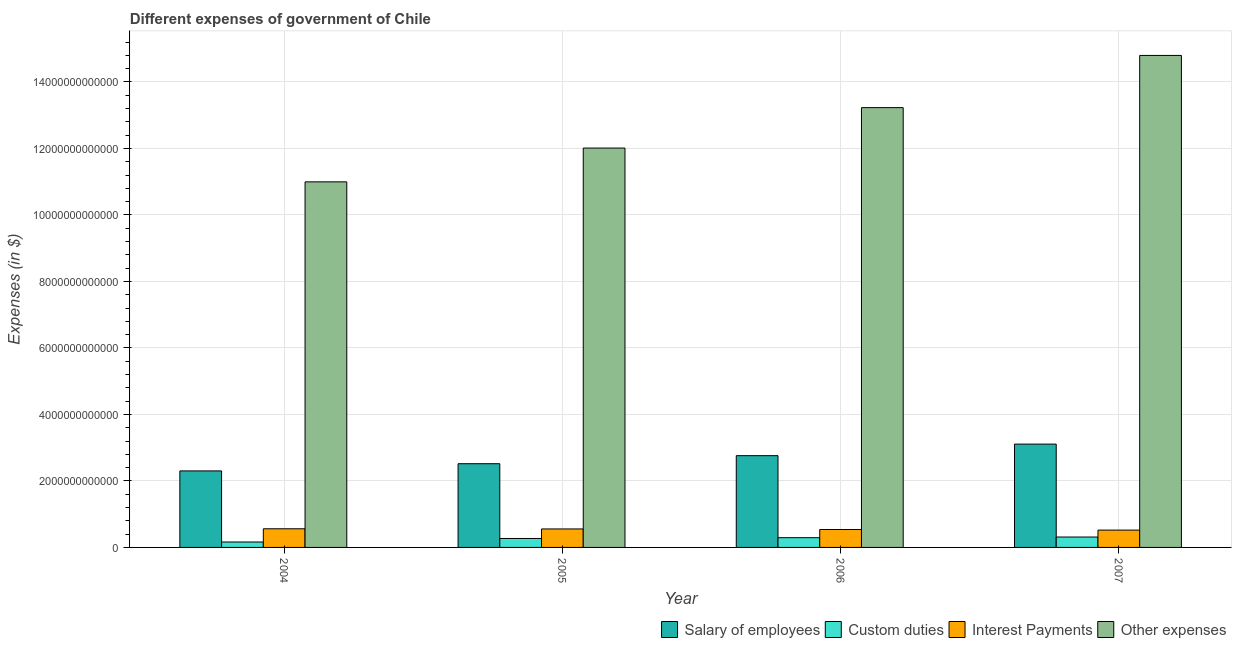How many different coloured bars are there?
Ensure brevity in your answer.  4. Are the number of bars per tick equal to the number of legend labels?
Make the answer very short. Yes. Are the number of bars on each tick of the X-axis equal?
Give a very brief answer. Yes. How many bars are there on the 1st tick from the right?
Provide a succinct answer. 4. In how many cases, is the number of bars for a given year not equal to the number of legend labels?
Ensure brevity in your answer.  0. What is the amount spent on salary of employees in 2004?
Make the answer very short. 2.30e+12. Across all years, what is the maximum amount spent on custom duties?
Offer a terse response. 3.13e+11. Across all years, what is the minimum amount spent on salary of employees?
Your answer should be very brief. 2.30e+12. What is the total amount spent on custom duties in the graph?
Give a very brief answer. 1.04e+12. What is the difference between the amount spent on other expenses in 2004 and that in 2007?
Ensure brevity in your answer.  -3.80e+12. What is the difference between the amount spent on other expenses in 2005 and the amount spent on custom duties in 2007?
Give a very brief answer. -2.79e+12. What is the average amount spent on other expenses per year?
Keep it short and to the point. 1.28e+13. In how many years, is the amount spent on interest payments greater than 5600000000000 $?
Your answer should be very brief. 0. What is the ratio of the amount spent on other expenses in 2004 to that in 2005?
Your answer should be very brief. 0.92. Is the amount spent on salary of employees in 2004 less than that in 2007?
Provide a short and direct response. Yes. Is the difference between the amount spent on interest payments in 2004 and 2006 greater than the difference between the amount spent on salary of employees in 2004 and 2006?
Offer a terse response. No. What is the difference between the highest and the second highest amount spent on custom duties?
Your answer should be compact. 2.01e+1. What is the difference between the highest and the lowest amount spent on interest payments?
Your answer should be very brief. 3.97e+1. What does the 2nd bar from the left in 2005 represents?
Make the answer very short. Custom duties. What does the 4th bar from the right in 2007 represents?
Keep it short and to the point. Salary of employees. How many bars are there?
Your answer should be compact. 16. How many years are there in the graph?
Offer a very short reply. 4. What is the difference between two consecutive major ticks on the Y-axis?
Provide a short and direct response. 2.00e+12. Does the graph contain any zero values?
Your answer should be compact. No. Where does the legend appear in the graph?
Your answer should be compact. Bottom right. How many legend labels are there?
Your answer should be very brief. 4. How are the legend labels stacked?
Make the answer very short. Horizontal. What is the title of the graph?
Ensure brevity in your answer.  Different expenses of government of Chile. Does "SF6 gas" appear as one of the legend labels in the graph?
Give a very brief answer. No. What is the label or title of the Y-axis?
Keep it short and to the point. Expenses (in $). What is the Expenses (in $) in Salary of employees in 2004?
Your answer should be compact. 2.30e+12. What is the Expenses (in $) of Custom duties in 2004?
Your answer should be very brief. 1.63e+11. What is the Expenses (in $) of Interest Payments in 2004?
Your answer should be very brief. 5.61e+11. What is the Expenses (in $) in Other expenses in 2004?
Your response must be concise. 1.10e+13. What is the Expenses (in $) in Salary of employees in 2005?
Your answer should be compact. 2.52e+12. What is the Expenses (in $) of Custom duties in 2005?
Offer a terse response. 2.69e+11. What is the Expenses (in $) of Interest Payments in 2005?
Provide a short and direct response. 5.56e+11. What is the Expenses (in $) in Other expenses in 2005?
Provide a succinct answer. 1.20e+13. What is the Expenses (in $) of Salary of employees in 2006?
Ensure brevity in your answer.  2.76e+12. What is the Expenses (in $) in Custom duties in 2006?
Provide a succinct answer. 2.93e+11. What is the Expenses (in $) of Interest Payments in 2006?
Your response must be concise. 5.39e+11. What is the Expenses (in $) of Other expenses in 2006?
Give a very brief answer. 1.32e+13. What is the Expenses (in $) in Salary of employees in 2007?
Offer a terse response. 3.11e+12. What is the Expenses (in $) of Custom duties in 2007?
Give a very brief answer. 3.13e+11. What is the Expenses (in $) of Interest Payments in 2007?
Provide a succinct answer. 5.21e+11. What is the Expenses (in $) in Other expenses in 2007?
Your answer should be very brief. 1.48e+13. Across all years, what is the maximum Expenses (in $) in Salary of employees?
Your answer should be compact. 3.11e+12. Across all years, what is the maximum Expenses (in $) in Custom duties?
Your answer should be compact. 3.13e+11. Across all years, what is the maximum Expenses (in $) of Interest Payments?
Keep it short and to the point. 5.61e+11. Across all years, what is the maximum Expenses (in $) of Other expenses?
Your answer should be very brief. 1.48e+13. Across all years, what is the minimum Expenses (in $) in Salary of employees?
Make the answer very short. 2.30e+12. Across all years, what is the minimum Expenses (in $) of Custom duties?
Provide a succinct answer. 1.63e+11. Across all years, what is the minimum Expenses (in $) of Interest Payments?
Make the answer very short. 5.21e+11. Across all years, what is the minimum Expenses (in $) in Other expenses?
Make the answer very short. 1.10e+13. What is the total Expenses (in $) in Salary of employees in the graph?
Provide a short and direct response. 1.07e+13. What is the total Expenses (in $) in Custom duties in the graph?
Offer a terse response. 1.04e+12. What is the total Expenses (in $) of Interest Payments in the graph?
Offer a very short reply. 2.18e+12. What is the total Expenses (in $) in Other expenses in the graph?
Your response must be concise. 5.10e+13. What is the difference between the Expenses (in $) in Salary of employees in 2004 and that in 2005?
Offer a terse response. -2.16e+11. What is the difference between the Expenses (in $) of Custom duties in 2004 and that in 2005?
Ensure brevity in your answer.  -1.06e+11. What is the difference between the Expenses (in $) in Interest Payments in 2004 and that in 2005?
Offer a terse response. 4.98e+09. What is the difference between the Expenses (in $) in Other expenses in 2004 and that in 2005?
Your response must be concise. -1.02e+12. What is the difference between the Expenses (in $) of Salary of employees in 2004 and that in 2006?
Make the answer very short. -4.58e+11. What is the difference between the Expenses (in $) of Custom duties in 2004 and that in 2006?
Offer a terse response. -1.30e+11. What is the difference between the Expenses (in $) of Interest Payments in 2004 and that in 2006?
Offer a terse response. 2.20e+1. What is the difference between the Expenses (in $) in Other expenses in 2004 and that in 2006?
Offer a very short reply. -2.23e+12. What is the difference between the Expenses (in $) in Salary of employees in 2004 and that in 2007?
Provide a short and direct response. -8.06e+11. What is the difference between the Expenses (in $) in Custom duties in 2004 and that in 2007?
Your answer should be compact. -1.50e+11. What is the difference between the Expenses (in $) of Interest Payments in 2004 and that in 2007?
Provide a short and direct response. 3.97e+1. What is the difference between the Expenses (in $) in Other expenses in 2004 and that in 2007?
Your answer should be very brief. -3.80e+12. What is the difference between the Expenses (in $) in Salary of employees in 2005 and that in 2006?
Ensure brevity in your answer.  -2.42e+11. What is the difference between the Expenses (in $) of Custom duties in 2005 and that in 2006?
Ensure brevity in your answer.  -2.38e+1. What is the difference between the Expenses (in $) in Interest Payments in 2005 and that in 2006?
Your response must be concise. 1.70e+1. What is the difference between the Expenses (in $) of Other expenses in 2005 and that in 2006?
Provide a succinct answer. -1.22e+12. What is the difference between the Expenses (in $) in Salary of employees in 2005 and that in 2007?
Ensure brevity in your answer.  -5.90e+11. What is the difference between the Expenses (in $) in Custom duties in 2005 and that in 2007?
Offer a very short reply. -4.39e+1. What is the difference between the Expenses (in $) in Interest Payments in 2005 and that in 2007?
Ensure brevity in your answer.  3.47e+1. What is the difference between the Expenses (in $) of Other expenses in 2005 and that in 2007?
Your response must be concise. -2.79e+12. What is the difference between the Expenses (in $) in Salary of employees in 2006 and that in 2007?
Keep it short and to the point. -3.48e+11. What is the difference between the Expenses (in $) in Custom duties in 2006 and that in 2007?
Give a very brief answer. -2.01e+1. What is the difference between the Expenses (in $) in Interest Payments in 2006 and that in 2007?
Your response must be concise. 1.77e+1. What is the difference between the Expenses (in $) in Other expenses in 2006 and that in 2007?
Ensure brevity in your answer.  -1.57e+12. What is the difference between the Expenses (in $) in Salary of employees in 2004 and the Expenses (in $) in Custom duties in 2005?
Give a very brief answer. 2.03e+12. What is the difference between the Expenses (in $) in Salary of employees in 2004 and the Expenses (in $) in Interest Payments in 2005?
Provide a succinct answer. 1.75e+12. What is the difference between the Expenses (in $) in Salary of employees in 2004 and the Expenses (in $) in Other expenses in 2005?
Your answer should be very brief. -9.71e+12. What is the difference between the Expenses (in $) in Custom duties in 2004 and the Expenses (in $) in Interest Payments in 2005?
Offer a very short reply. -3.93e+11. What is the difference between the Expenses (in $) of Custom duties in 2004 and the Expenses (in $) of Other expenses in 2005?
Your answer should be compact. -1.19e+13. What is the difference between the Expenses (in $) in Interest Payments in 2004 and the Expenses (in $) in Other expenses in 2005?
Provide a succinct answer. -1.15e+13. What is the difference between the Expenses (in $) in Salary of employees in 2004 and the Expenses (in $) in Custom duties in 2006?
Give a very brief answer. 2.01e+12. What is the difference between the Expenses (in $) of Salary of employees in 2004 and the Expenses (in $) of Interest Payments in 2006?
Your response must be concise. 1.76e+12. What is the difference between the Expenses (in $) in Salary of employees in 2004 and the Expenses (in $) in Other expenses in 2006?
Offer a terse response. -1.09e+13. What is the difference between the Expenses (in $) of Custom duties in 2004 and the Expenses (in $) of Interest Payments in 2006?
Your answer should be compact. -3.76e+11. What is the difference between the Expenses (in $) of Custom duties in 2004 and the Expenses (in $) of Other expenses in 2006?
Ensure brevity in your answer.  -1.31e+13. What is the difference between the Expenses (in $) of Interest Payments in 2004 and the Expenses (in $) of Other expenses in 2006?
Your answer should be compact. -1.27e+13. What is the difference between the Expenses (in $) in Salary of employees in 2004 and the Expenses (in $) in Custom duties in 2007?
Make the answer very short. 1.99e+12. What is the difference between the Expenses (in $) of Salary of employees in 2004 and the Expenses (in $) of Interest Payments in 2007?
Give a very brief answer. 1.78e+12. What is the difference between the Expenses (in $) in Salary of employees in 2004 and the Expenses (in $) in Other expenses in 2007?
Your answer should be very brief. -1.25e+13. What is the difference between the Expenses (in $) in Custom duties in 2004 and the Expenses (in $) in Interest Payments in 2007?
Offer a very short reply. -3.58e+11. What is the difference between the Expenses (in $) in Custom duties in 2004 and the Expenses (in $) in Other expenses in 2007?
Provide a short and direct response. -1.46e+13. What is the difference between the Expenses (in $) of Interest Payments in 2004 and the Expenses (in $) of Other expenses in 2007?
Make the answer very short. -1.42e+13. What is the difference between the Expenses (in $) of Salary of employees in 2005 and the Expenses (in $) of Custom duties in 2006?
Your answer should be very brief. 2.23e+12. What is the difference between the Expenses (in $) of Salary of employees in 2005 and the Expenses (in $) of Interest Payments in 2006?
Make the answer very short. 1.98e+12. What is the difference between the Expenses (in $) of Salary of employees in 2005 and the Expenses (in $) of Other expenses in 2006?
Make the answer very short. -1.07e+13. What is the difference between the Expenses (in $) of Custom duties in 2005 and the Expenses (in $) of Interest Payments in 2006?
Your response must be concise. -2.70e+11. What is the difference between the Expenses (in $) of Custom duties in 2005 and the Expenses (in $) of Other expenses in 2006?
Keep it short and to the point. -1.30e+13. What is the difference between the Expenses (in $) in Interest Payments in 2005 and the Expenses (in $) in Other expenses in 2006?
Make the answer very short. -1.27e+13. What is the difference between the Expenses (in $) in Salary of employees in 2005 and the Expenses (in $) in Custom duties in 2007?
Provide a short and direct response. 2.20e+12. What is the difference between the Expenses (in $) in Salary of employees in 2005 and the Expenses (in $) in Interest Payments in 2007?
Your answer should be compact. 2.00e+12. What is the difference between the Expenses (in $) in Salary of employees in 2005 and the Expenses (in $) in Other expenses in 2007?
Give a very brief answer. -1.23e+13. What is the difference between the Expenses (in $) in Custom duties in 2005 and the Expenses (in $) in Interest Payments in 2007?
Your response must be concise. -2.52e+11. What is the difference between the Expenses (in $) of Custom duties in 2005 and the Expenses (in $) of Other expenses in 2007?
Offer a very short reply. -1.45e+13. What is the difference between the Expenses (in $) in Interest Payments in 2005 and the Expenses (in $) in Other expenses in 2007?
Offer a terse response. -1.42e+13. What is the difference between the Expenses (in $) of Salary of employees in 2006 and the Expenses (in $) of Custom duties in 2007?
Your response must be concise. 2.45e+12. What is the difference between the Expenses (in $) in Salary of employees in 2006 and the Expenses (in $) in Interest Payments in 2007?
Provide a short and direct response. 2.24e+12. What is the difference between the Expenses (in $) in Salary of employees in 2006 and the Expenses (in $) in Other expenses in 2007?
Offer a very short reply. -1.20e+13. What is the difference between the Expenses (in $) of Custom duties in 2006 and the Expenses (in $) of Interest Payments in 2007?
Keep it short and to the point. -2.28e+11. What is the difference between the Expenses (in $) in Custom duties in 2006 and the Expenses (in $) in Other expenses in 2007?
Make the answer very short. -1.45e+13. What is the difference between the Expenses (in $) in Interest Payments in 2006 and the Expenses (in $) in Other expenses in 2007?
Your response must be concise. -1.43e+13. What is the average Expenses (in $) of Salary of employees per year?
Your answer should be very brief. 2.67e+12. What is the average Expenses (in $) in Custom duties per year?
Provide a succinct answer. 2.60e+11. What is the average Expenses (in $) of Interest Payments per year?
Your answer should be very brief. 5.44e+11. What is the average Expenses (in $) of Other expenses per year?
Offer a terse response. 1.28e+13. In the year 2004, what is the difference between the Expenses (in $) of Salary of employees and Expenses (in $) of Custom duties?
Keep it short and to the point. 2.14e+12. In the year 2004, what is the difference between the Expenses (in $) of Salary of employees and Expenses (in $) of Interest Payments?
Your answer should be compact. 1.74e+12. In the year 2004, what is the difference between the Expenses (in $) in Salary of employees and Expenses (in $) in Other expenses?
Provide a succinct answer. -8.69e+12. In the year 2004, what is the difference between the Expenses (in $) in Custom duties and Expenses (in $) in Interest Payments?
Keep it short and to the point. -3.98e+11. In the year 2004, what is the difference between the Expenses (in $) in Custom duties and Expenses (in $) in Other expenses?
Your answer should be very brief. -1.08e+13. In the year 2004, what is the difference between the Expenses (in $) in Interest Payments and Expenses (in $) in Other expenses?
Give a very brief answer. -1.04e+13. In the year 2005, what is the difference between the Expenses (in $) of Salary of employees and Expenses (in $) of Custom duties?
Your answer should be very brief. 2.25e+12. In the year 2005, what is the difference between the Expenses (in $) in Salary of employees and Expenses (in $) in Interest Payments?
Provide a succinct answer. 1.96e+12. In the year 2005, what is the difference between the Expenses (in $) in Salary of employees and Expenses (in $) in Other expenses?
Your answer should be very brief. -9.50e+12. In the year 2005, what is the difference between the Expenses (in $) in Custom duties and Expenses (in $) in Interest Payments?
Offer a very short reply. -2.87e+11. In the year 2005, what is the difference between the Expenses (in $) in Custom duties and Expenses (in $) in Other expenses?
Your answer should be very brief. -1.17e+13. In the year 2005, what is the difference between the Expenses (in $) in Interest Payments and Expenses (in $) in Other expenses?
Provide a short and direct response. -1.15e+13. In the year 2006, what is the difference between the Expenses (in $) of Salary of employees and Expenses (in $) of Custom duties?
Offer a terse response. 2.47e+12. In the year 2006, what is the difference between the Expenses (in $) of Salary of employees and Expenses (in $) of Interest Payments?
Your answer should be very brief. 2.22e+12. In the year 2006, what is the difference between the Expenses (in $) in Salary of employees and Expenses (in $) in Other expenses?
Keep it short and to the point. -1.05e+13. In the year 2006, what is the difference between the Expenses (in $) of Custom duties and Expenses (in $) of Interest Payments?
Keep it short and to the point. -2.46e+11. In the year 2006, what is the difference between the Expenses (in $) in Custom duties and Expenses (in $) in Other expenses?
Offer a very short reply. -1.29e+13. In the year 2006, what is the difference between the Expenses (in $) in Interest Payments and Expenses (in $) in Other expenses?
Offer a very short reply. -1.27e+13. In the year 2007, what is the difference between the Expenses (in $) in Salary of employees and Expenses (in $) in Custom duties?
Your answer should be compact. 2.79e+12. In the year 2007, what is the difference between the Expenses (in $) of Salary of employees and Expenses (in $) of Interest Payments?
Give a very brief answer. 2.59e+12. In the year 2007, what is the difference between the Expenses (in $) in Salary of employees and Expenses (in $) in Other expenses?
Ensure brevity in your answer.  -1.17e+13. In the year 2007, what is the difference between the Expenses (in $) in Custom duties and Expenses (in $) in Interest Payments?
Make the answer very short. -2.08e+11. In the year 2007, what is the difference between the Expenses (in $) of Custom duties and Expenses (in $) of Other expenses?
Your answer should be very brief. -1.45e+13. In the year 2007, what is the difference between the Expenses (in $) in Interest Payments and Expenses (in $) in Other expenses?
Provide a succinct answer. -1.43e+13. What is the ratio of the Expenses (in $) in Salary of employees in 2004 to that in 2005?
Your answer should be very brief. 0.91. What is the ratio of the Expenses (in $) in Custom duties in 2004 to that in 2005?
Your answer should be very brief. 0.61. What is the ratio of the Expenses (in $) of Other expenses in 2004 to that in 2005?
Offer a terse response. 0.92. What is the ratio of the Expenses (in $) of Salary of employees in 2004 to that in 2006?
Provide a short and direct response. 0.83. What is the ratio of the Expenses (in $) in Custom duties in 2004 to that in 2006?
Provide a short and direct response. 0.56. What is the ratio of the Expenses (in $) in Interest Payments in 2004 to that in 2006?
Give a very brief answer. 1.04. What is the ratio of the Expenses (in $) in Other expenses in 2004 to that in 2006?
Ensure brevity in your answer.  0.83. What is the ratio of the Expenses (in $) in Salary of employees in 2004 to that in 2007?
Provide a short and direct response. 0.74. What is the ratio of the Expenses (in $) in Custom duties in 2004 to that in 2007?
Offer a terse response. 0.52. What is the ratio of the Expenses (in $) in Interest Payments in 2004 to that in 2007?
Make the answer very short. 1.08. What is the ratio of the Expenses (in $) in Other expenses in 2004 to that in 2007?
Give a very brief answer. 0.74. What is the ratio of the Expenses (in $) of Salary of employees in 2005 to that in 2006?
Offer a very short reply. 0.91. What is the ratio of the Expenses (in $) in Custom duties in 2005 to that in 2006?
Your answer should be very brief. 0.92. What is the ratio of the Expenses (in $) of Interest Payments in 2005 to that in 2006?
Keep it short and to the point. 1.03. What is the ratio of the Expenses (in $) in Other expenses in 2005 to that in 2006?
Give a very brief answer. 0.91. What is the ratio of the Expenses (in $) in Salary of employees in 2005 to that in 2007?
Your answer should be compact. 0.81. What is the ratio of the Expenses (in $) of Custom duties in 2005 to that in 2007?
Ensure brevity in your answer.  0.86. What is the ratio of the Expenses (in $) in Interest Payments in 2005 to that in 2007?
Your answer should be compact. 1.07. What is the ratio of the Expenses (in $) in Other expenses in 2005 to that in 2007?
Make the answer very short. 0.81. What is the ratio of the Expenses (in $) in Salary of employees in 2006 to that in 2007?
Your answer should be compact. 0.89. What is the ratio of the Expenses (in $) in Custom duties in 2006 to that in 2007?
Keep it short and to the point. 0.94. What is the ratio of the Expenses (in $) of Interest Payments in 2006 to that in 2007?
Offer a terse response. 1.03. What is the ratio of the Expenses (in $) of Other expenses in 2006 to that in 2007?
Ensure brevity in your answer.  0.89. What is the difference between the highest and the second highest Expenses (in $) in Salary of employees?
Make the answer very short. 3.48e+11. What is the difference between the highest and the second highest Expenses (in $) of Custom duties?
Offer a terse response. 2.01e+1. What is the difference between the highest and the second highest Expenses (in $) of Interest Payments?
Keep it short and to the point. 4.98e+09. What is the difference between the highest and the second highest Expenses (in $) in Other expenses?
Offer a terse response. 1.57e+12. What is the difference between the highest and the lowest Expenses (in $) in Salary of employees?
Offer a terse response. 8.06e+11. What is the difference between the highest and the lowest Expenses (in $) in Custom duties?
Your answer should be very brief. 1.50e+11. What is the difference between the highest and the lowest Expenses (in $) in Interest Payments?
Ensure brevity in your answer.  3.97e+1. What is the difference between the highest and the lowest Expenses (in $) in Other expenses?
Provide a short and direct response. 3.80e+12. 